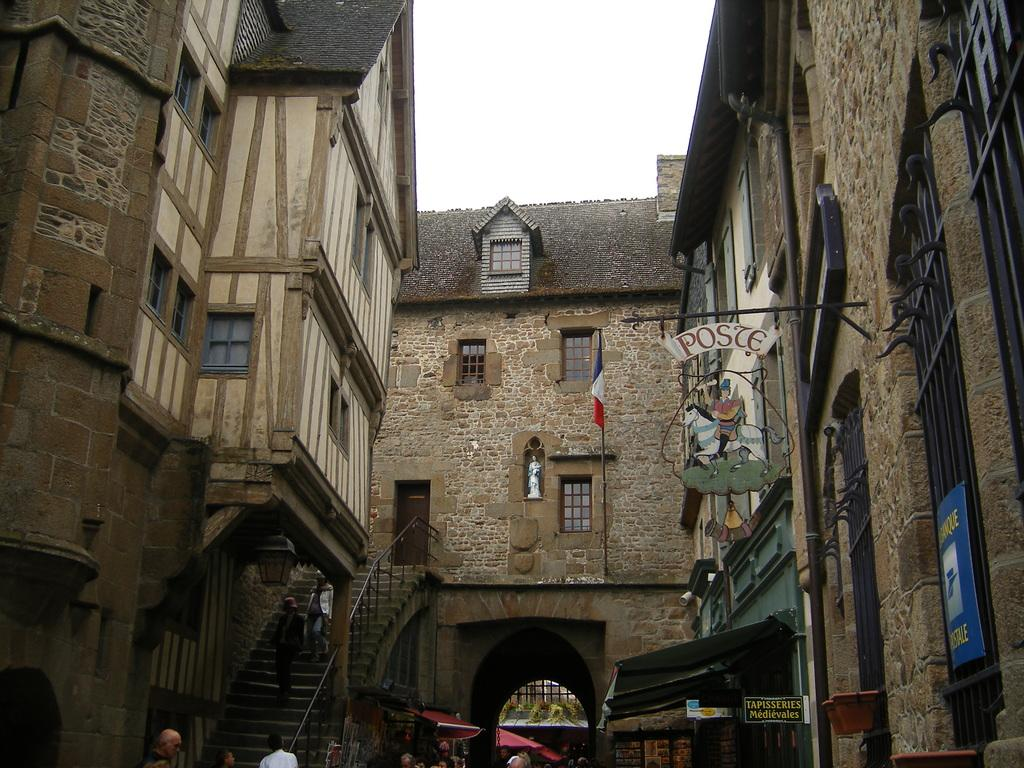What type of structures can be seen in the image? There are buildings in the image. What objects are present that might be used for displaying information or advertisements? There are boards in the image. What objects are present that might be used for cooking or grilling food? There are grills in the image. What temporary shelters can be seen in the image? There are tents in the image. What architectural feature is present that allows access to the buildings? There are steps in the image. What part of the buildings allow light and air to enter? There are windows in the image. What type of artwork or sculpture can be seen in the image? There is a statue in the image. Who or what is present in the image besides the structures and objects? There are people in the image. What can be seen in the background of the image? The sky is visible in the background of the image. How does the rain affect the grills in the image? There is no rain present in the image, so the grills are not affected by rain. What type of flight can be seen in the image? There is no flight present in the image, so no such activity can be observed. 